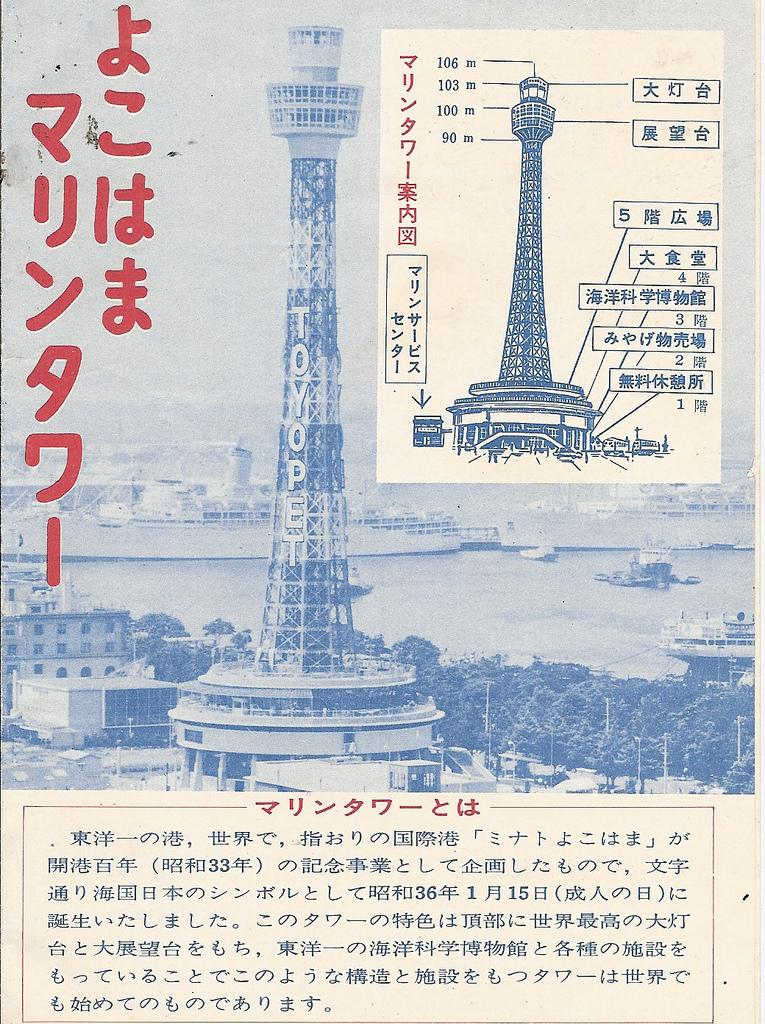What type of material is the main subject of the image? The image is a paper. What is featured on the paper? There is an article on the paper. What types of images are included in the article? The article contains images of buildings, trees, and water. What can be seen in the water in the images? There are ships visible in the water. Is there any text on the paper? Yes, there is text written on the paper. What type of meal is being prepared in the image? There is no meal being prepared in the image; it is a paper with an article containing images of buildings, trees, and water. What function does the calculator serve in the image? There is no calculator present in the image. 